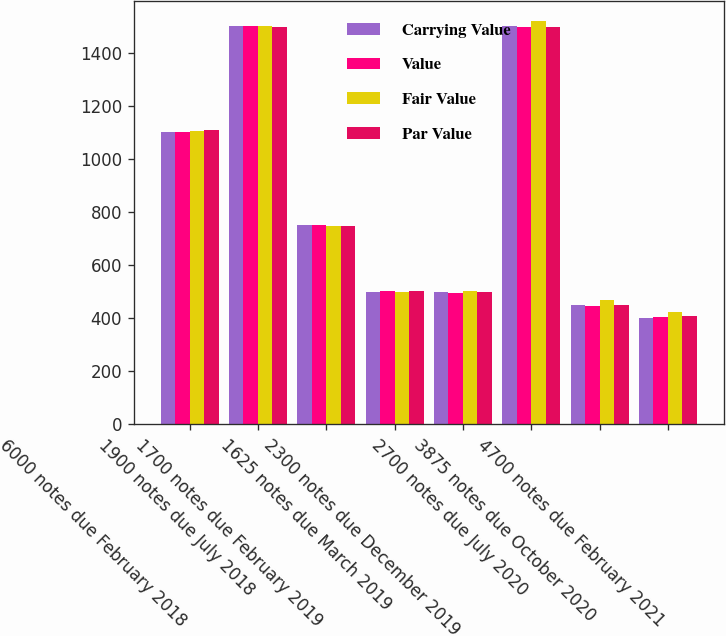Convert chart to OTSL. <chart><loc_0><loc_0><loc_500><loc_500><stacked_bar_chart><ecel><fcel>6000 notes due February 2018<fcel>1900 notes due July 2018<fcel>1700 notes due February 2019<fcel>1625 notes due March 2019<fcel>2300 notes due December 2019<fcel>2700 notes due July 2020<fcel>3875 notes due October 2020<fcel>4700 notes due February 2021<nl><fcel>Carrying Value<fcel>1100<fcel>1500<fcel>750<fcel>500<fcel>500<fcel>1500<fcel>450<fcel>400<nl><fcel>Value<fcel>1101<fcel>1499<fcel>749<fcel>501<fcel>495<fcel>1496<fcel>446<fcel>403<nl><fcel>Fair Value<fcel>1106<fcel>1501<fcel>747<fcel>497<fcel>501<fcel>1517<fcel>467<fcel>425<nl><fcel>Par Value<fcel>1107<fcel>1496<fcel>748<fcel>501<fcel>498<fcel>1495<fcel>450<fcel>409<nl></chart> 